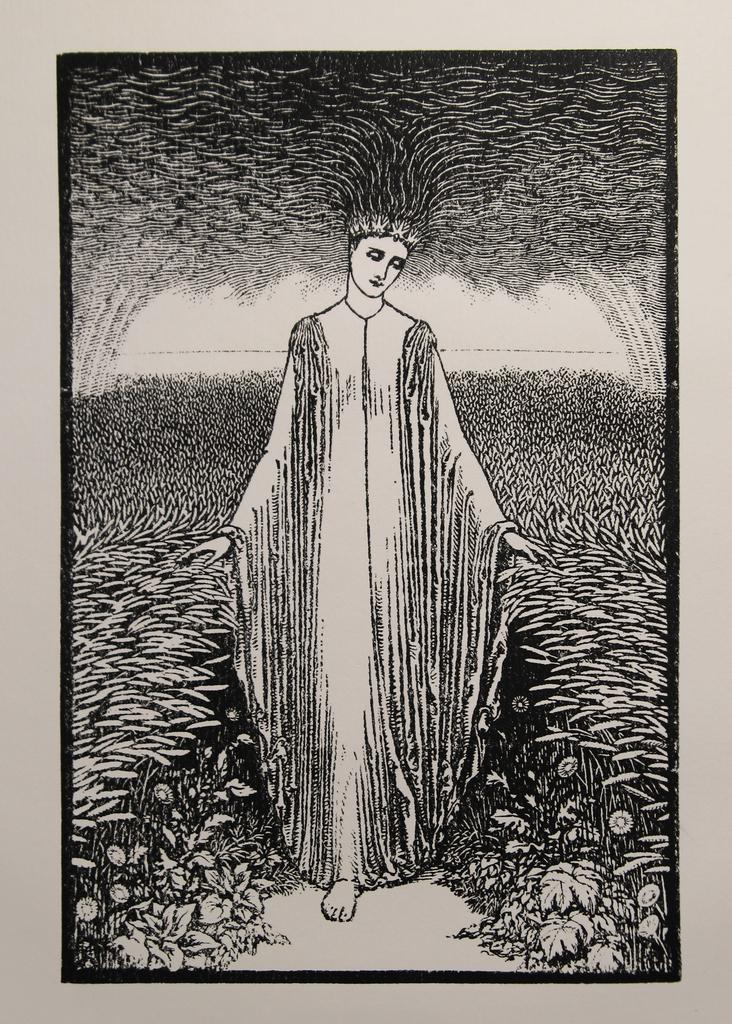What is placed on the platform in the image? There is a photo frame on a platform. What is inside the photo frame? The photo frame contains a drawing. What is the subject of the drawing? The drawing depicts a woman standing on a path. What can be seen on both sides of the woman in the drawing? There are plants on either side of the woman in the drawing. What type of noise can be heard coming from the popcorn in the image? There is no popcorn present in the image, so it's not possible to determine what, if any, noise might be heard. 